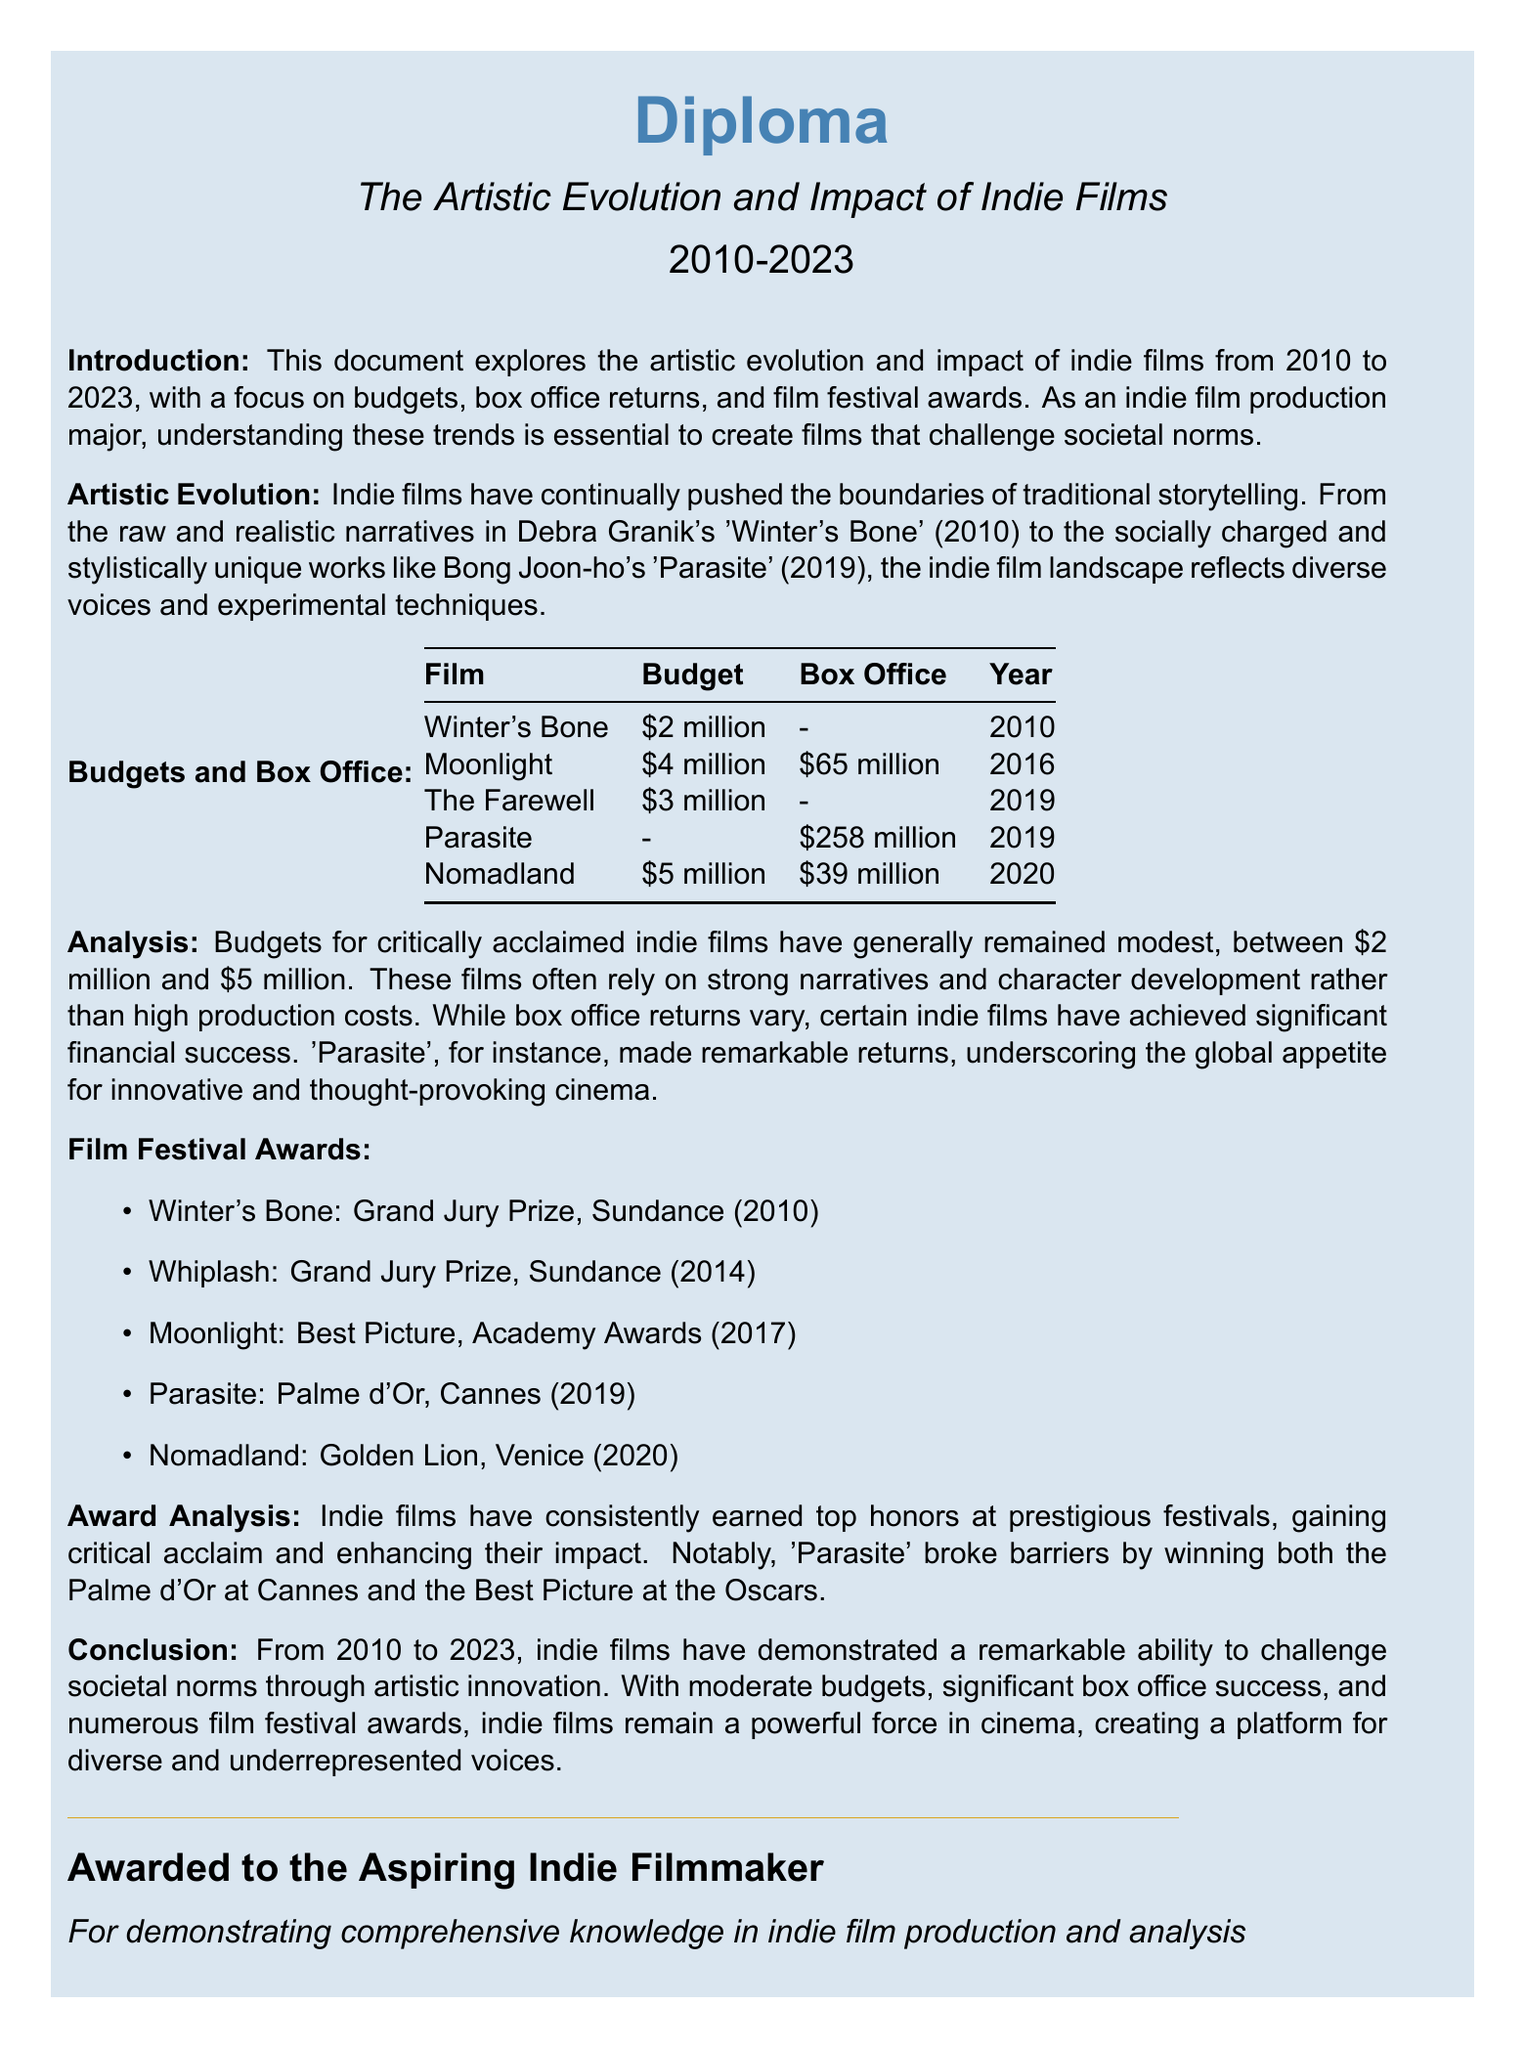What is the highest box office return listed? The highest box office return is from the film "Parasite" in 2019, which made $258 million.
Answer: $258 million What year did "Moonlight" win Best Picture? "Moonlight" won Best Picture at the Academy Awards in 2017.
Answer: 2017 How much was the budget for "Nomadland"? The budget for "Nomadland" is given as $5 million.
Answer: $5 million Which indie film received the Grand Jury Prize at Sundance in 2010? "Winter's Bone" received the Grand Jury Prize at Sundance in 2010.
Answer: Winter's Bone What significant achievement did "Parasite" accomplish at Cannes? "Parasite" won the Palme d'Or at Cannes in 2019, marking a significant achievement.
Answer: Palme d'Or What trend is noted regarding the budgets of successful indie films? The document notes that budgets for critically acclaimed indie films generally remain modest, between $2 million and $5 million.
Answer: Modest budgets Which film was released in 2019 and had a budget of $3 million? "The Farewell" was released in 2019 and had a budget of $3 million.
Answer: The Farewell What is the title of the diploma? The title of the diploma is "The Artistic Evolution and Impact of Indie Films".
Answer: The Artistic Evolution and Impact of Indie Films How many awards did "Nomadland" win at the Venice Film Festival? "Nomadland" won the Golden Lion at the Venice Film Festival.
Answer: Golden Lion 